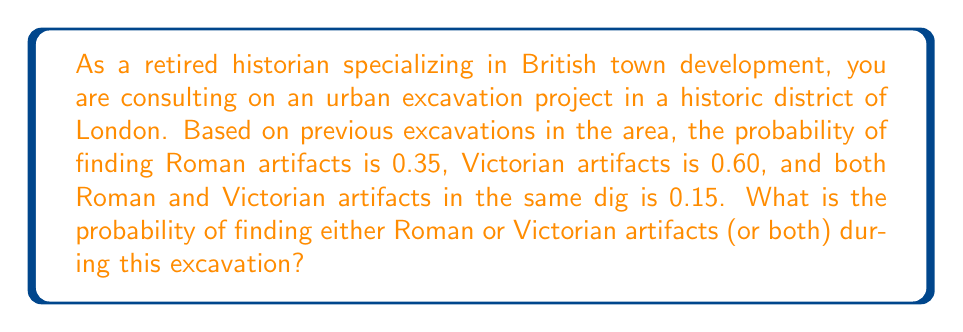Show me your answer to this math problem. To solve this problem, we'll use the addition rule of probability. Let's define our events:

R: Finding Roman artifacts
V: Finding Victorian artifacts

We're given:
P(R) = 0.35
P(V) = 0.60
P(R ∩ V) = 0.15 (probability of finding both)

We want to find P(R ∪ V), the probability of finding either Roman or Victorian artifacts (or both).

The addition rule of probability states:

$$ P(R \cup V) = P(R) + P(V) - P(R \cap V) $$

This is because if we simply add P(R) and P(V), we would be double-counting the instances where both types of artifacts are found. So we need to subtract P(R ∩ V) once to correct for this.

Substituting our values:

$$ P(R \cup V) = 0.35 + 0.60 - 0.15 $$

$$ P(R \cup V) = 0.95 - 0.15 = 0.80 $$

Therefore, the probability of finding either Roman or Victorian artifacts (or both) is 0.80 or 80%.
Answer: 0.80 or 80% 